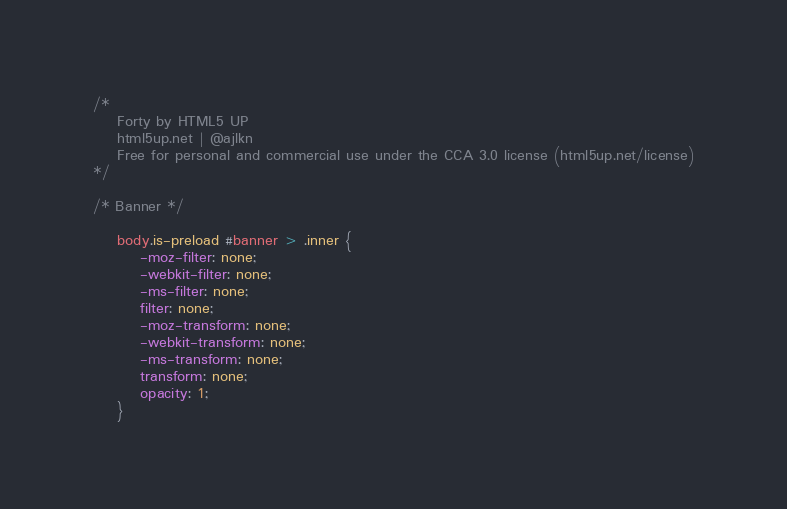Convert code to text. <code><loc_0><loc_0><loc_500><loc_500><_CSS_>/*
	Forty by HTML5 UP
	html5up.net | @ajlkn
	Free for personal and commercial use under the CCA 3.0 license (html5up.net/license)
*/

/* Banner */

	body.is-preload #banner > .inner {
		-moz-filter: none;
		-webkit-filter: none;
		-ms-filter: none;
		filter: none;
		-moz-transform: none;
		-webkit-transform: none;
		-ms-transform: none;
		transform: none;
		opacity: 1;
	}</code> 